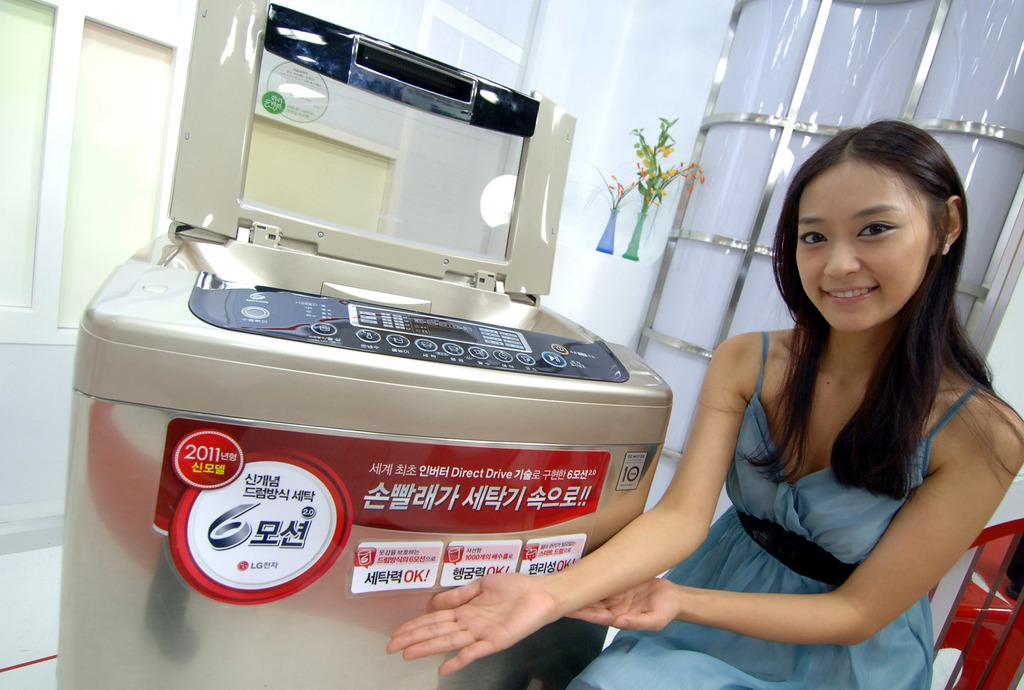<image>
Render a clear and concise summary of the photo. a woman displays a machine by LG with Korean letters on it 